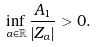<formula> <loc_0><loc_0><loc_500><loc_500>\inf _ { \alpha \in \mathbb { R } } \frac { A _ { 1 } } { | Z _ { \alpha } | } > 0 .</formula> 